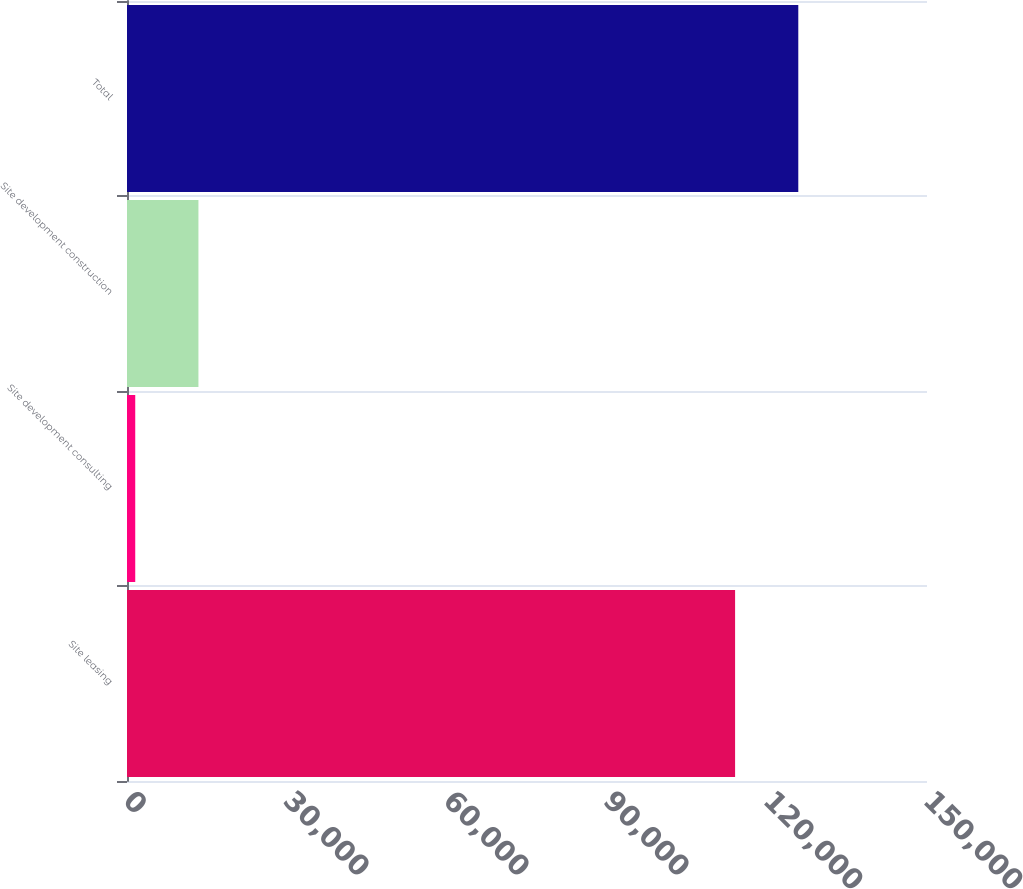Convert chart to OTSL. <chart><loc_0><loc_0><loc_500><loc_500><bar_chart><fcel>Site leasing<fcel>Site development consulting<fcel>Site development construction<fcel>Total<nl><fcel>114018<fcel>1545<fcel>13394.4<fcel>125867<nl></chart> 